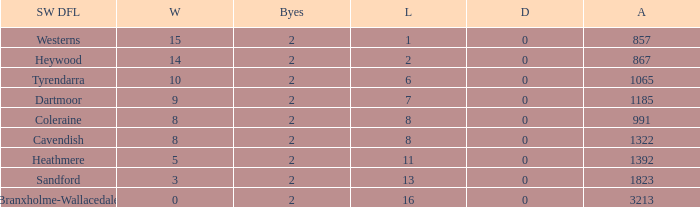How many wins have 16 losses and an Against smaller than 3213? None. 